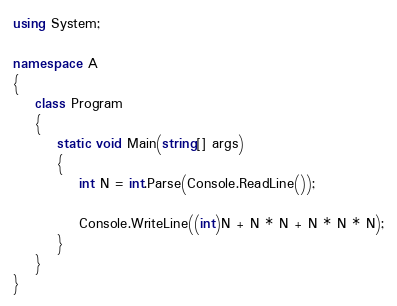Convert code to text. <code><loc_0><loc_0><loc_500><loc_500><_C#_>using System;

namespace A
{
    class Program
    {
        static void Main(string[] args)
        {
            int N = int.Parse(Console.ReadLine());

            Console.WriteLine((int)N + N * N + N * N * N);
        }
    }
}
</code> 